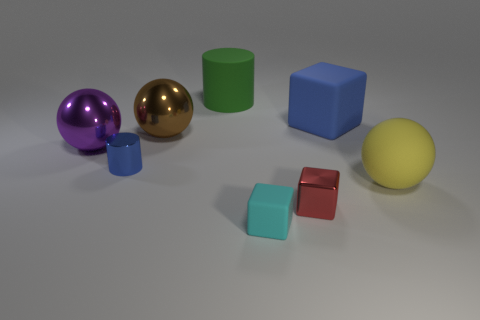What number of metal cylinders are the same color as the big rubber block? There are two metal cylinders in the image, one golden and the other purple. The big rubber block is blue, and there are no metal cylinders of the same color. Therefore, the number of metal cylinders that match the big rubber block's color is zero. 